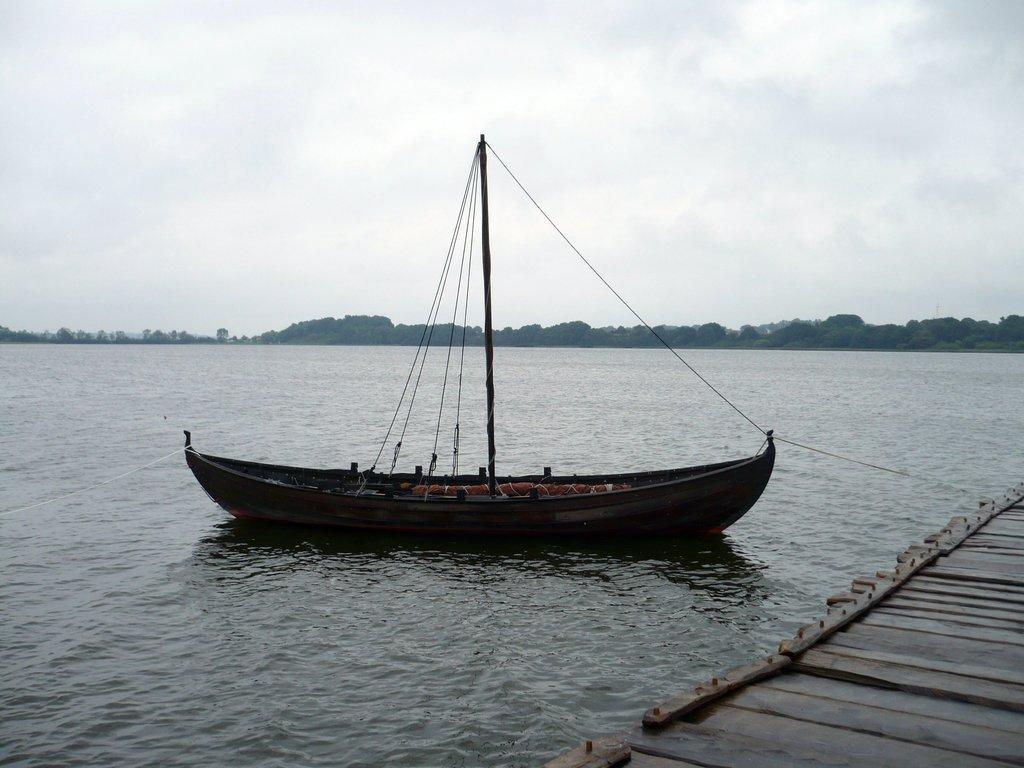Can you describe this image briefly? In this image, we can see a ship sailing on the water. There are a few trees. We can see the sky. 